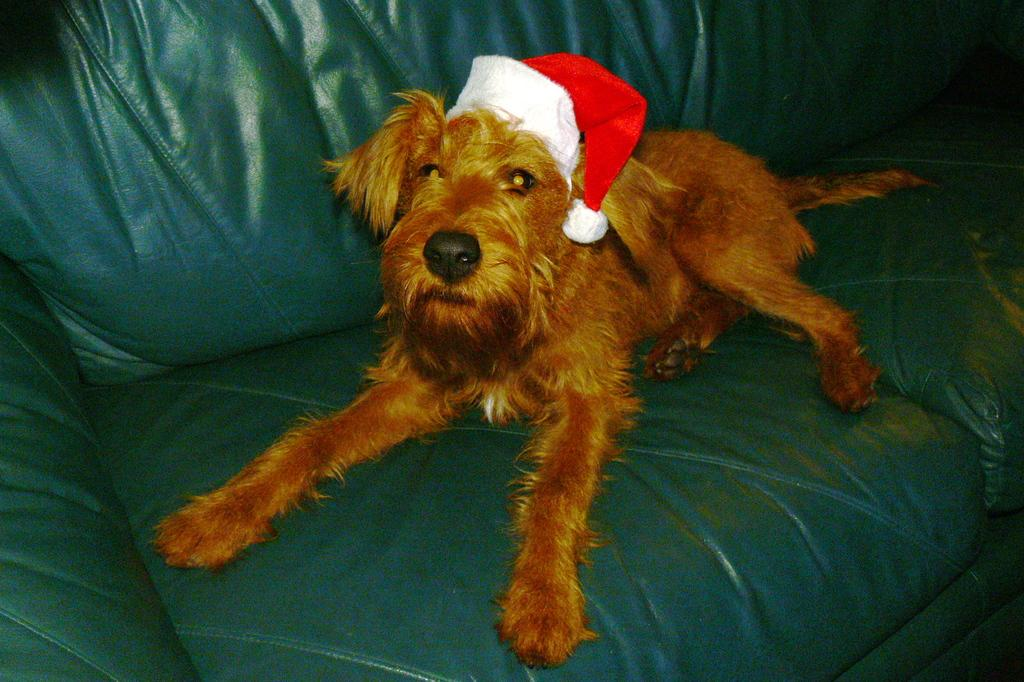What color is the couch in the image? The couch in the image is green. What is on the couch? There is a brown dog on the couch. What is the dog wearing? The dog is wearing a hat. What type of locket is hanging from the dog's neck in the image? There is no locket present in the image; the dog is only wearing a hat. 